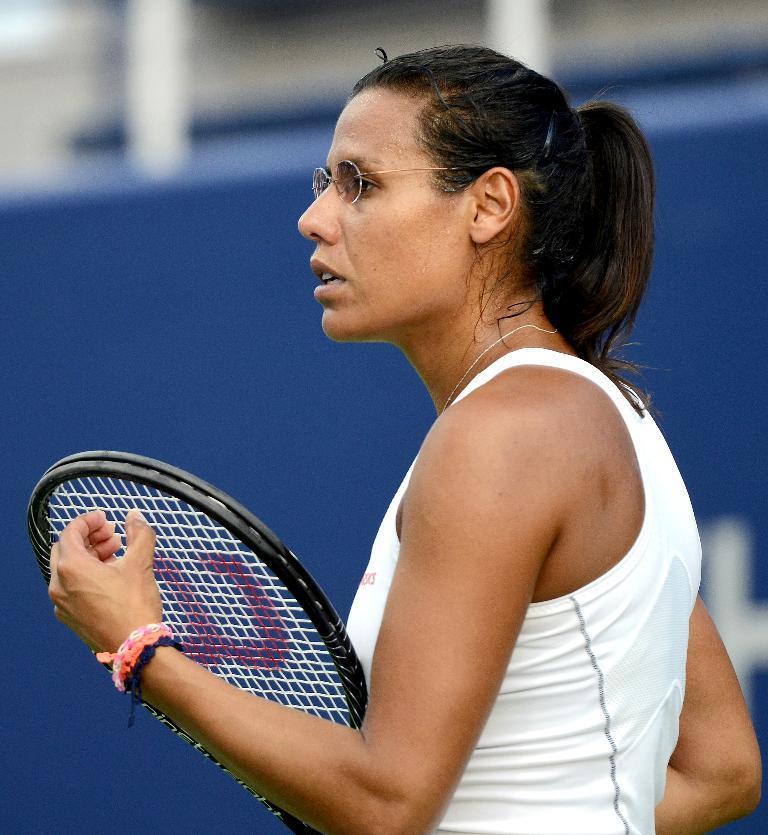In one or two sentences, can you explain what this image depicts? In the picture there is a woman holding tennis racket in her hand,she is wearing spectacles and white shirt and the background of the women is blur. 